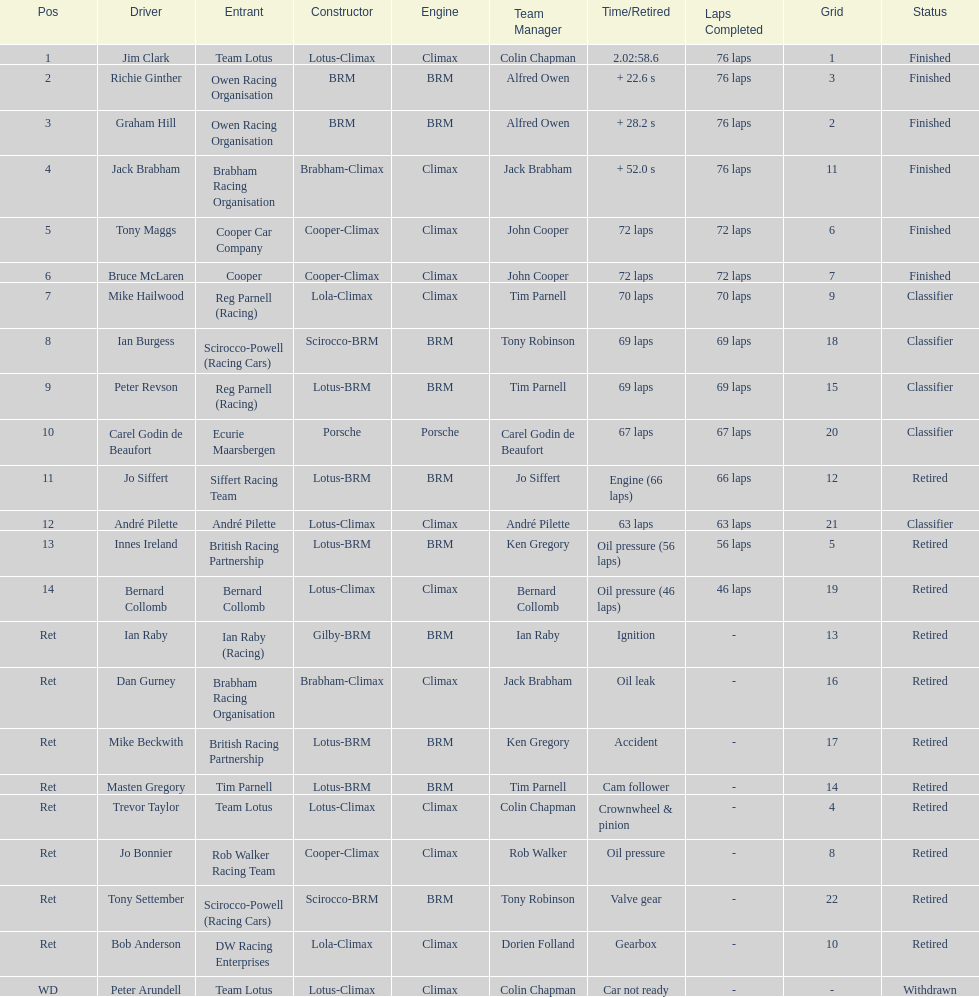What country had the least number of drivers, germany or the uk? Germany. 